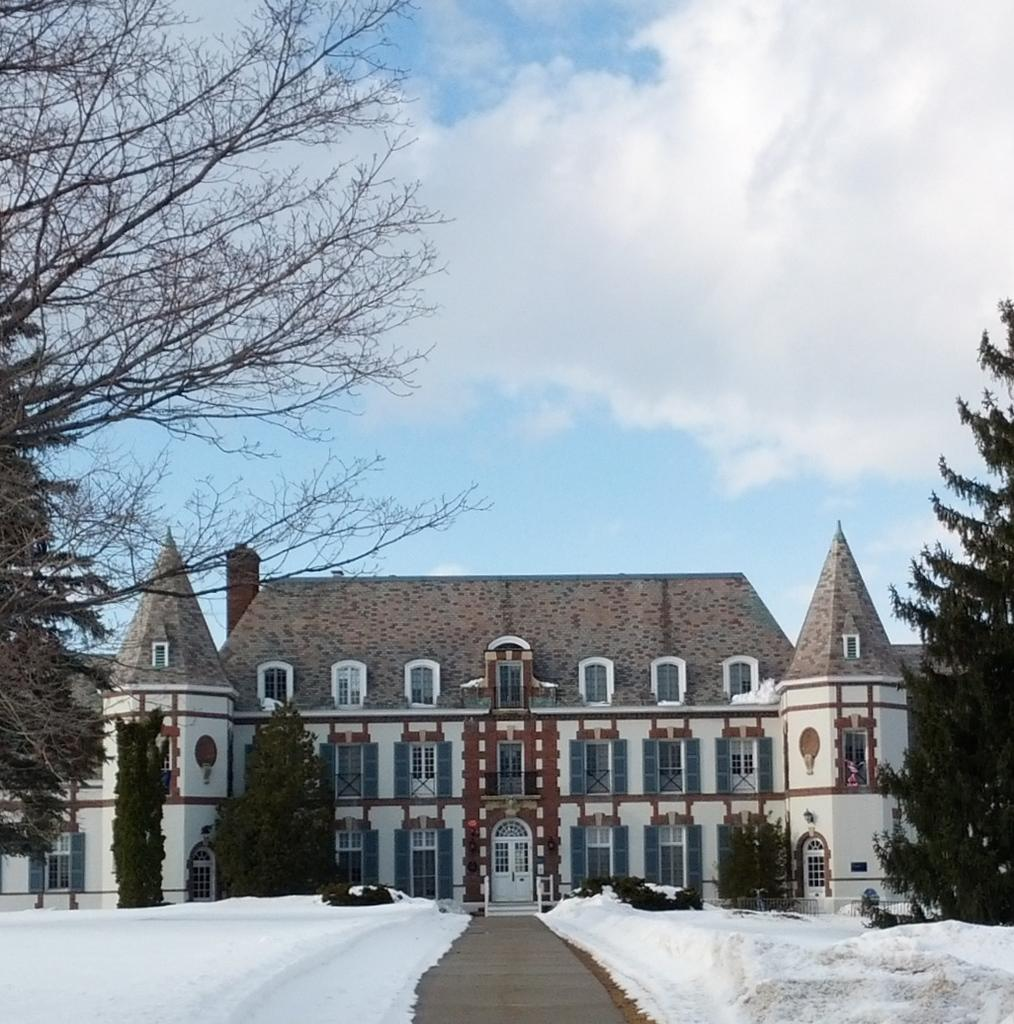What type of weather is depicted in the image? There is snow in the image, indicating cold weather. What type of vegetation can be seen in the image? There are plants and trees in the image. What type of structure is visible in the image? There is a building in the image. What is visible in the background of the image? The sky is visible in the background of the image. How many cushions are on the ground in the image? There are no cushions present in the image. What type of lace is draped over the trees in the image? There is no lace present in the image; it features snow, plants, trees, a building, and the sky. 